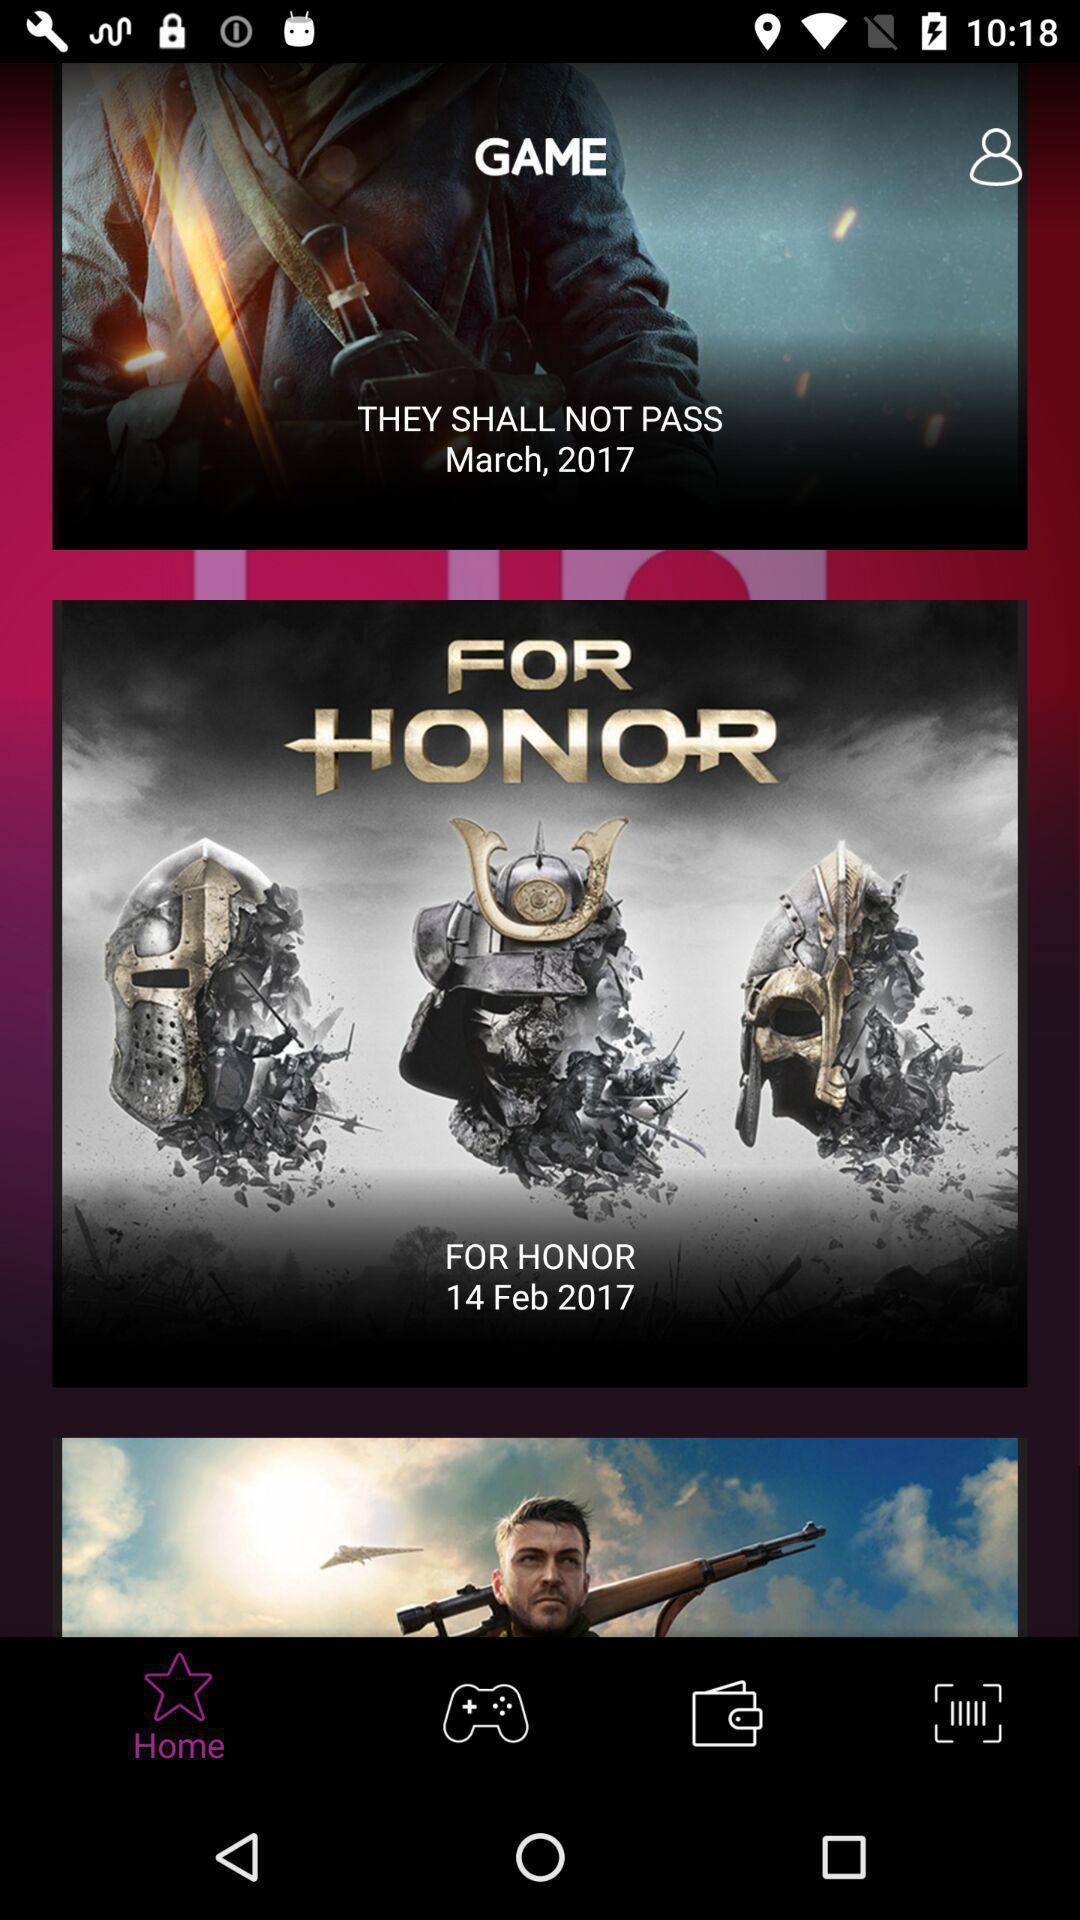Provide a detailed account of this screenshot. They shall not pass in game. 